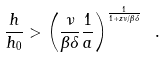<formula> <loc_0><loc_0><loc_500><loc_500>\frac { h } { h _ { 0 } } > \left ( \frac { \nu } { \beta \delta } \frac { 1 } { a } \right ) ^ { \frac { 1 } { 1 + z \nu / \beta \delta } } \ .</formula> 